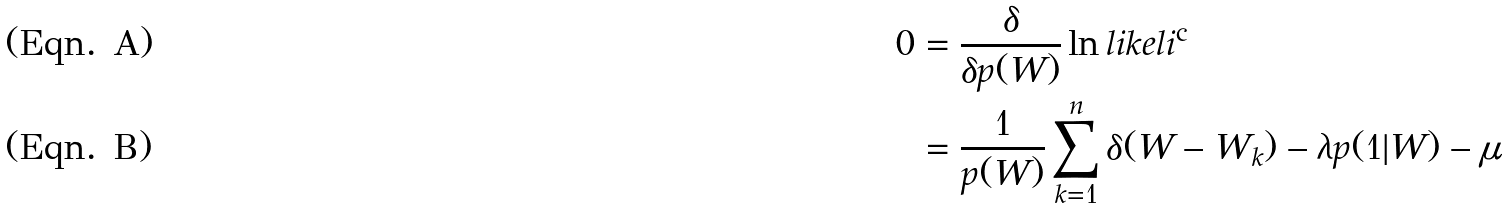<formula> <loc_0><loc_0><loc_500><loc_500>0 & = \frac { \delta } { \delta p ( W ) } \ln l i k e l i ^ { \text {c} } \\ & = \frac { 1 } { p ( W ) } \sum _ { k = 1 } ^ { n } \delta ( W - W _ { k } ) - \lambda p ( 1 | W ) - \mu</formula> 